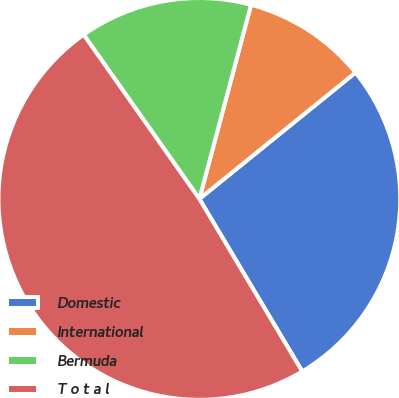<chart> <loc_0><loc_0><loc_500><loc_500><pie_chart><fcel>Domestic<fcel>International<fcel>Bermuda<fcel>T o t a l<nl><fcel>27.27%<fcel>10.03%<fcel>13.91%<fcel>48.79%<nl></chart> 